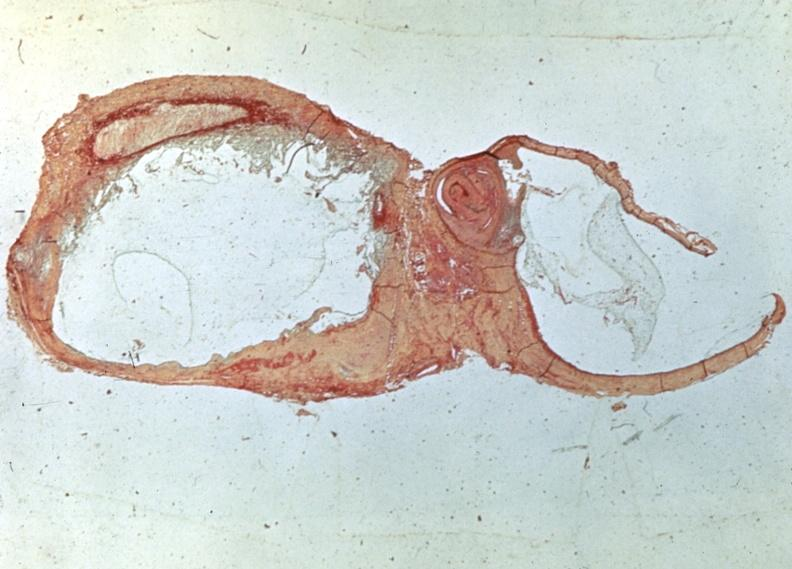does this image show popliteal cyst myxoid?
Answer the question using a single word or phrase. Yes 